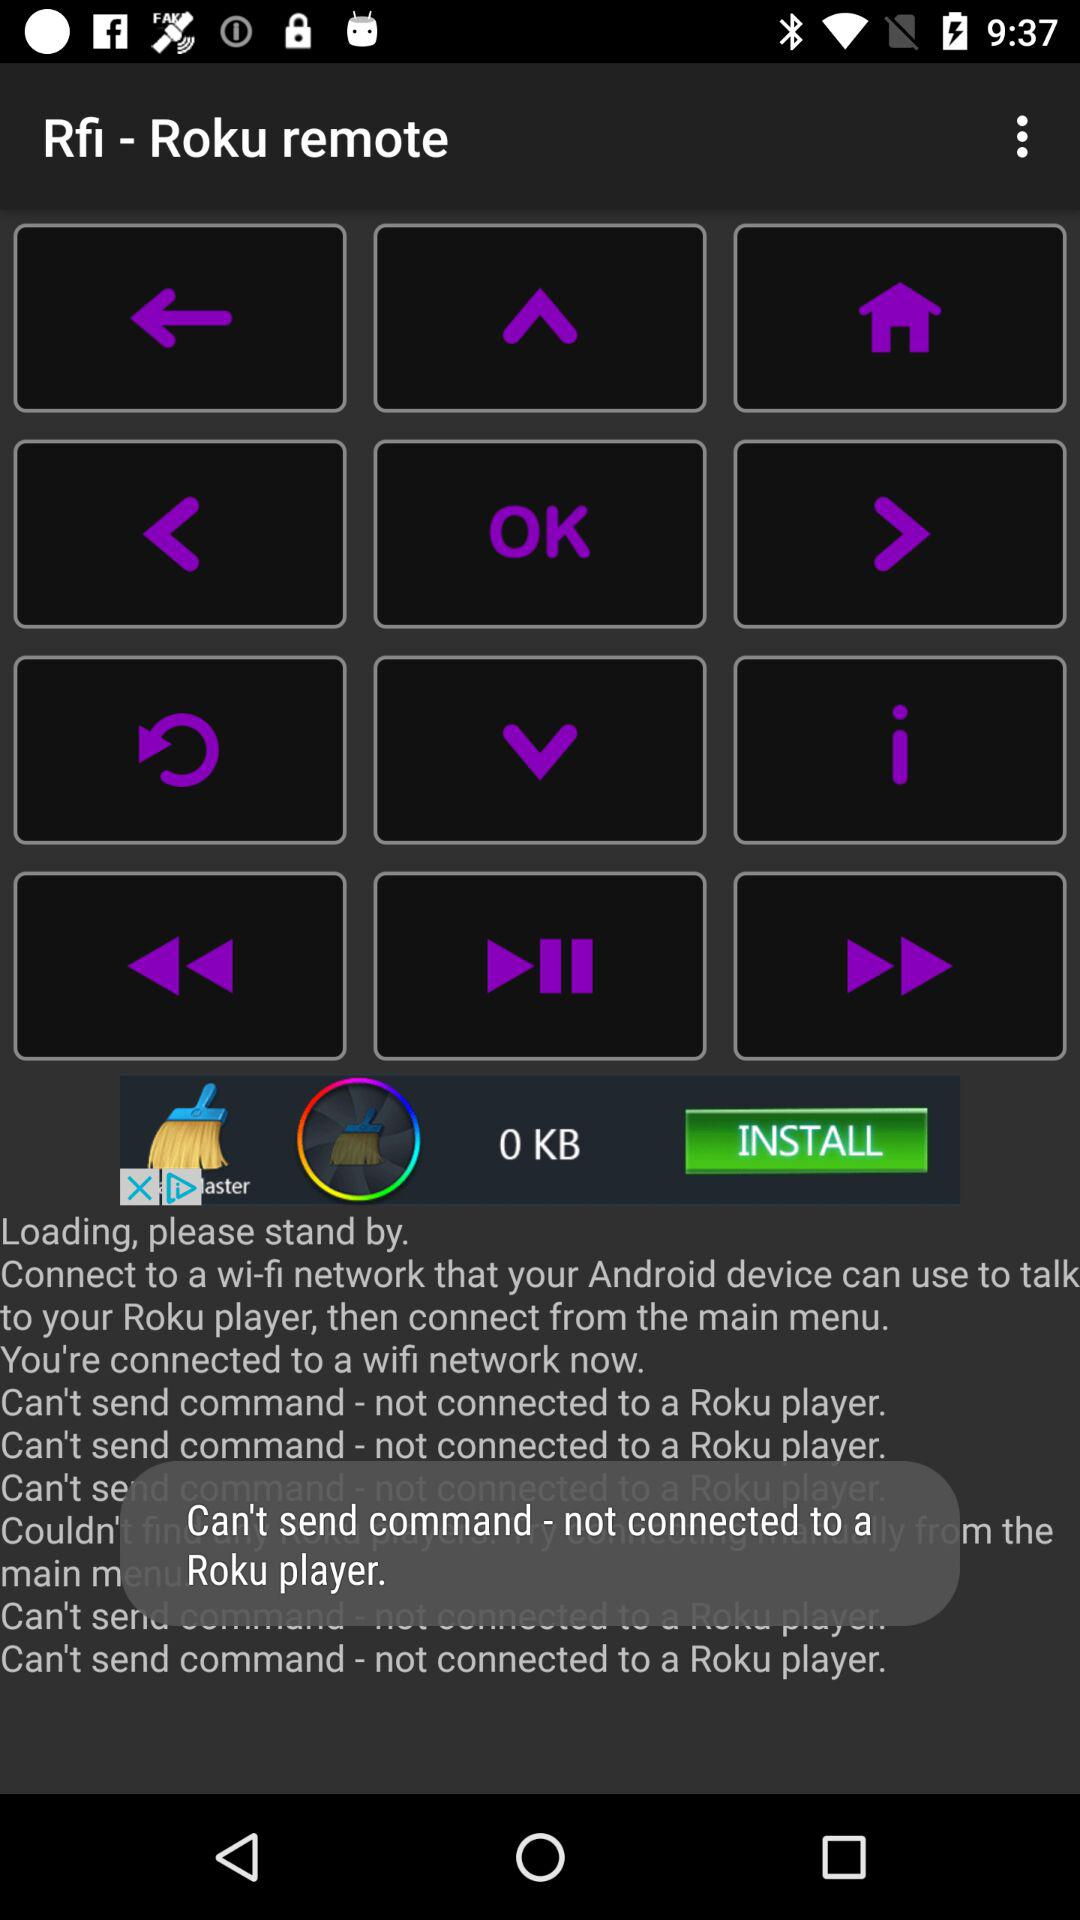Is the Roku player connected? The Roku player is not connected. 